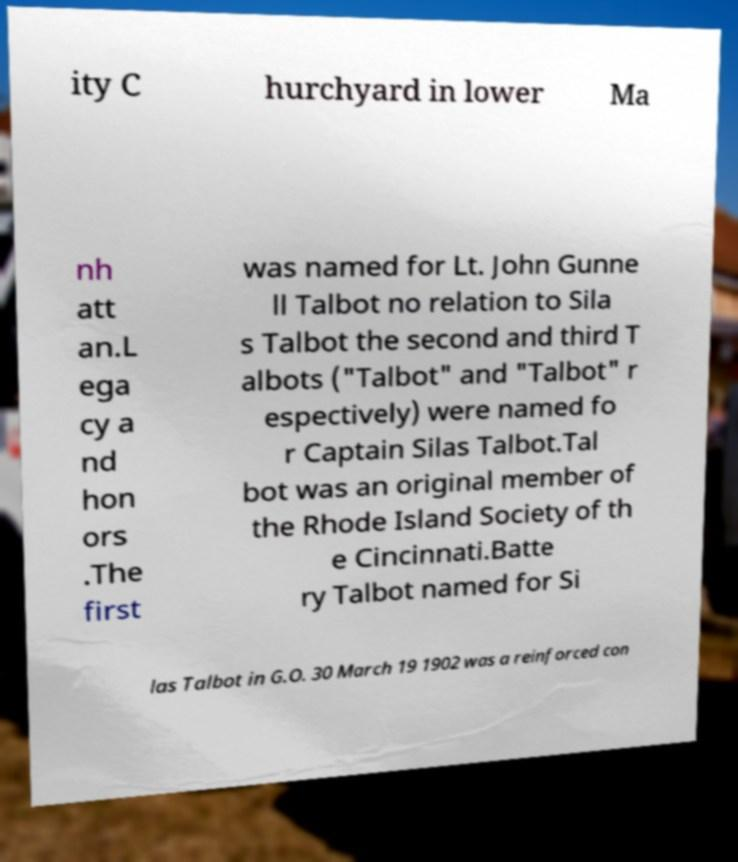What messages or text are displayed in this image? I need them in a readable, typed format. ity C hurchyard in lower Ma nh att an.L ega cy a nd hon ors .The first was named for Lt. John Gunne ll Talbot no relation to Sila s Talbot the second and third T albots ("Talbot" and "Talbot" r espectively) were named fo r Captain Silas Talbot.Tal bot was an original member of the Rhode Island Society of th e Cincinnati.Batte ry Talbot named for Si las Talbot in G.O. 30 March 19 1902 was a reinforced con 